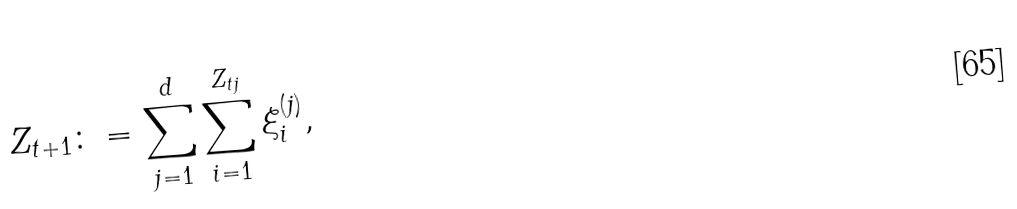Convert formula to latex. <formula><loc_0><loc_0><loc_500><loc_500>Z _ { t + 1 } & \colon = \sum _ { j = 1 } ^ { d } \sum _ { i = 1 } ^ { Z _ { t j } } \xi _ { i } ^ { ( j ) } ,</formula> 